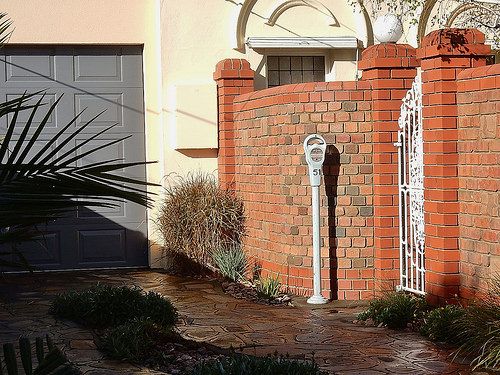<image>
Is there a gate in front of the brick? No. The gate is not in front of the brick. The spatial positioning shows a different relationship between these objects. 